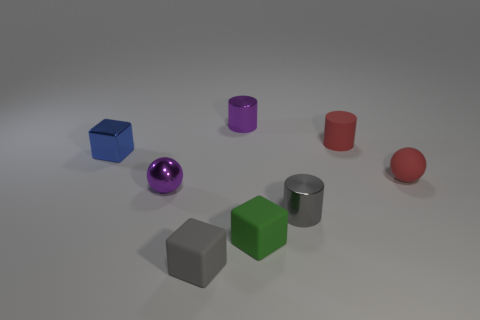Are there fewer red things than matte things?
Your response must be concise. Yes. There is a tiny gray cylinder; are there any cylinders to the right of it?
Your answer should be compact. Yes. What is the shape of the thing that is both behind the red sphere and on the right side of the gray cylinder?
Provide a short and direct response. Cylinder. Is there a blue metal thing that has the same shape as the tiny green matte object?
Keep it short and to the point. Yes. Are there more blue shiny cubes than purple rubber cubes?
Keep it short and to the point. Yes. How many purple cylinders have the same material as the blue block?
Give a very brief answer. 1. Is the shape of the blue object the same as the tiny gray shiny thing?
Your response must be concise. No. There is a matte block right of the metal cylinder behind the small purple thing to the left of the gray rubber object; what size is it?
Give a very brief answer. Small. Is there a metallic block behind the cube that is on the right side of the gray matte object?
Give a very brief answer. Yes. There is a small gray thing to the right of the small gray thing that is to the left of the small green rubber thing; how many small red balls are in front of it?
Provide a succinct answer. 0. 